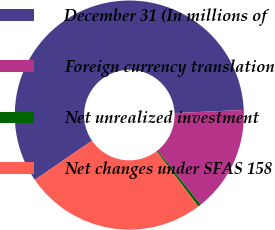<chart> <loc_0><loc_0><loc_500><loc_500><pie_chart><fcel>December 31 (In millions of<fcel>Foreign currency translation<fcel>Net unrealized investment<fcel>Net changes under SFAS 158<nl><fcel>58.86%<fcel>15.01%<fcel>0.41%<fcel>25.72%<nl></chart> 